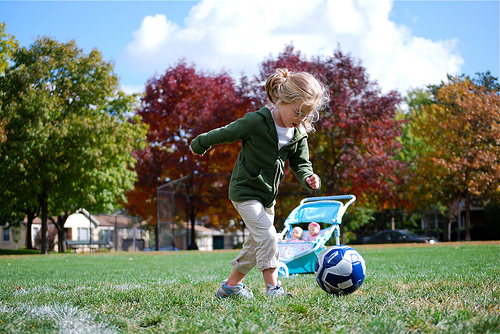<image>
Can you confirm if the kid is above the ball? No. The kid is not positioned above the ball. The vertical arrangement shows a different relationship. Is the doll above the park? No. The doll is not positioned above the park. The vertical arrangement shows a different relationship. Is the girl behind the tree? No. The girl is not behind the tree. From this viewpoint, the girl appears to be positioned elsewhere in the scene. 